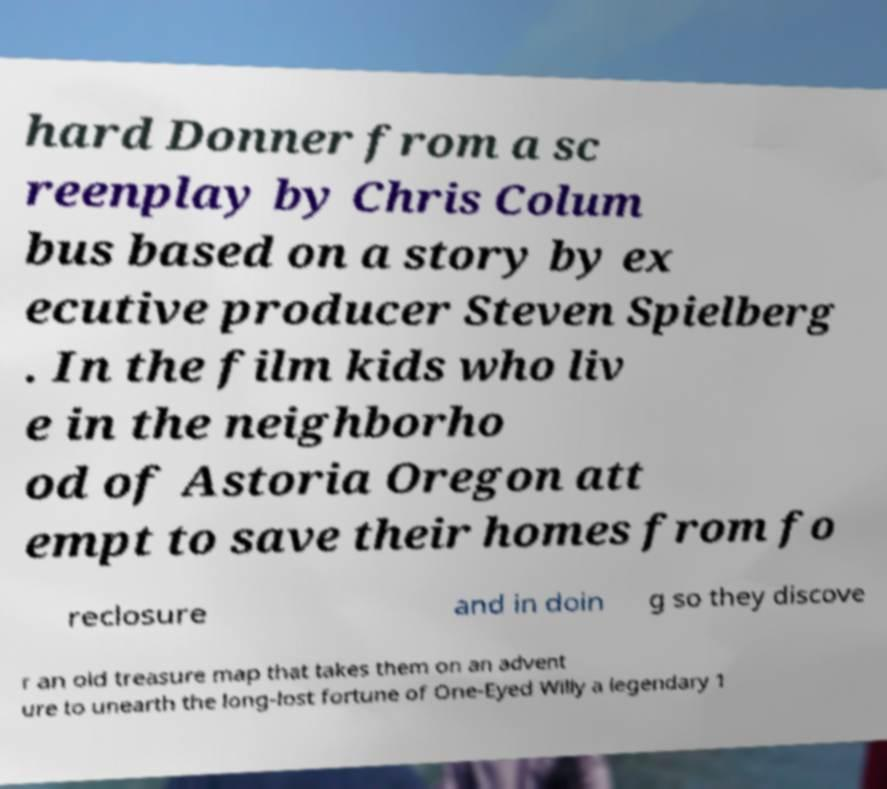There's text embedded in this image that I need extracted. Can you transcribe it verbatim? hard Donner from a sc reenplay by Chris Colum bus based on a story by ex ecutive producer Steven Spielberg . In the film kids who liv e in the neighborho od of Astoria Oregon att empt to save their homes from fo reclosure and in doin g so they discove r an old treasure map that takes them on an advent ure to unearth the long-lost fortune of One-Eyed Willy a legendary 1 